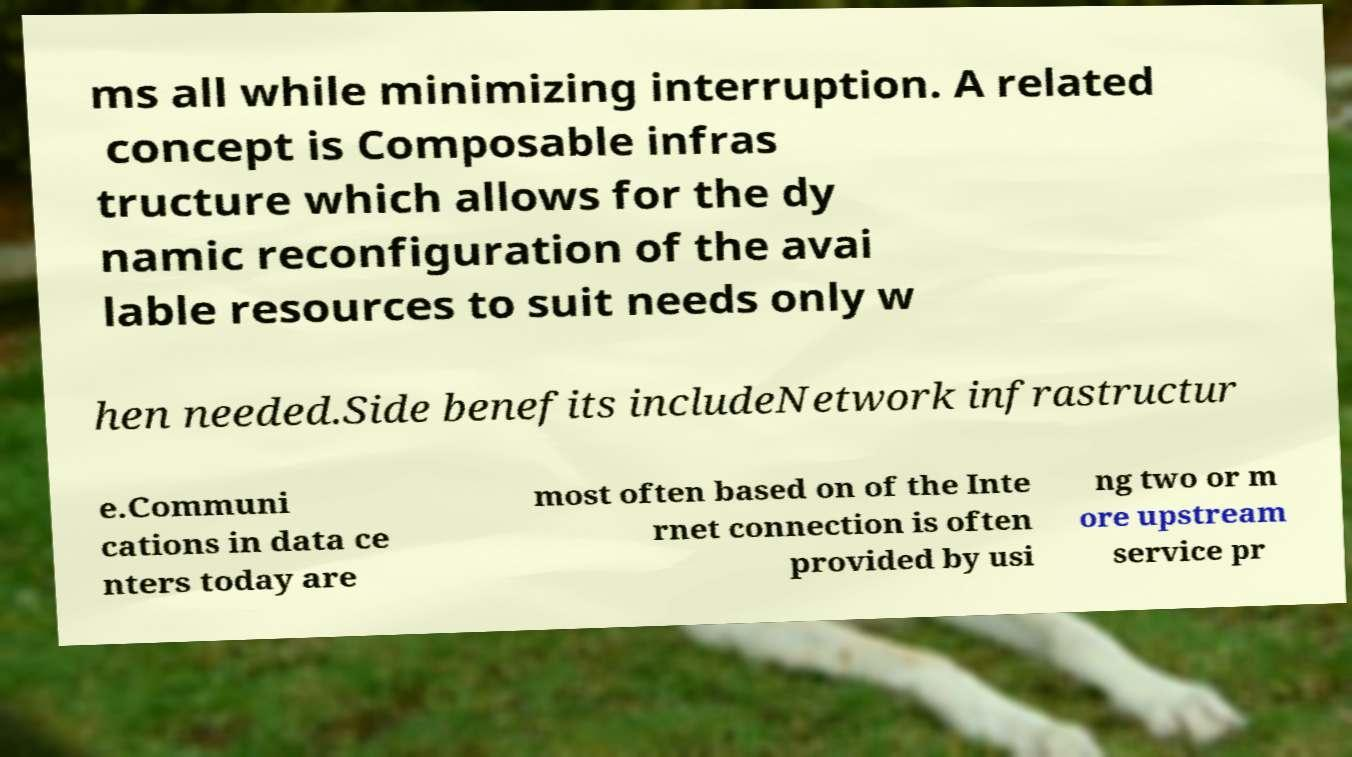Could you assist in decoding the text presented in this image and type it out clearly? ms all while minimizing interruption. A related concept is Composable infras tructure which allows for the dy namic reconfiguration of the avai lable resources to suit needs only w hen needed.Side benefits includeNetwork infrastructur e.Communi cations in data ce nters today are most often based on of the Inte rnet connection is often provided by usi ng two or m ore upstream service pr 